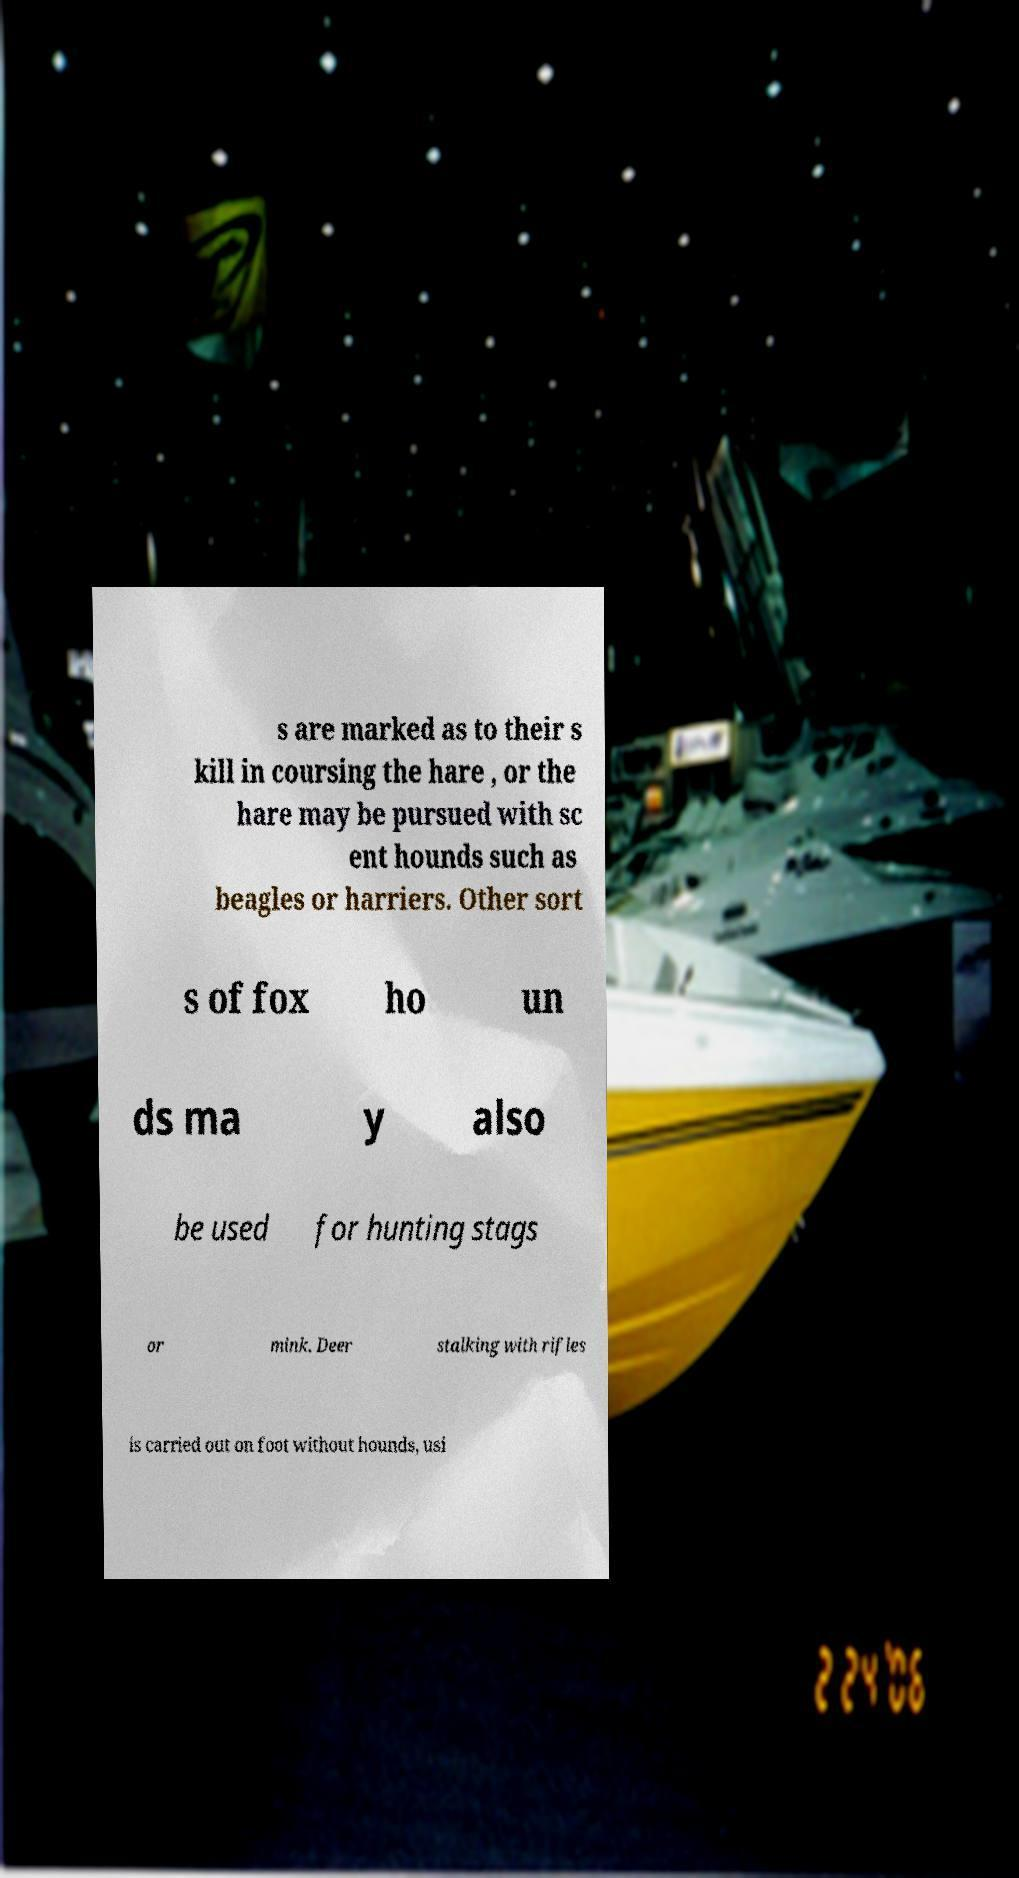I need the written content from this picture converted into text. Can you do that? s are marked as to their s kill in coursing the hare , or the hare may be pursued with sc ent hounds such as beagles or harriers. Other sort s of fox ho un ds ma y also be used for hunting stags or mink. Deer stalking with rifles is carried out on foot without hounds, usi 